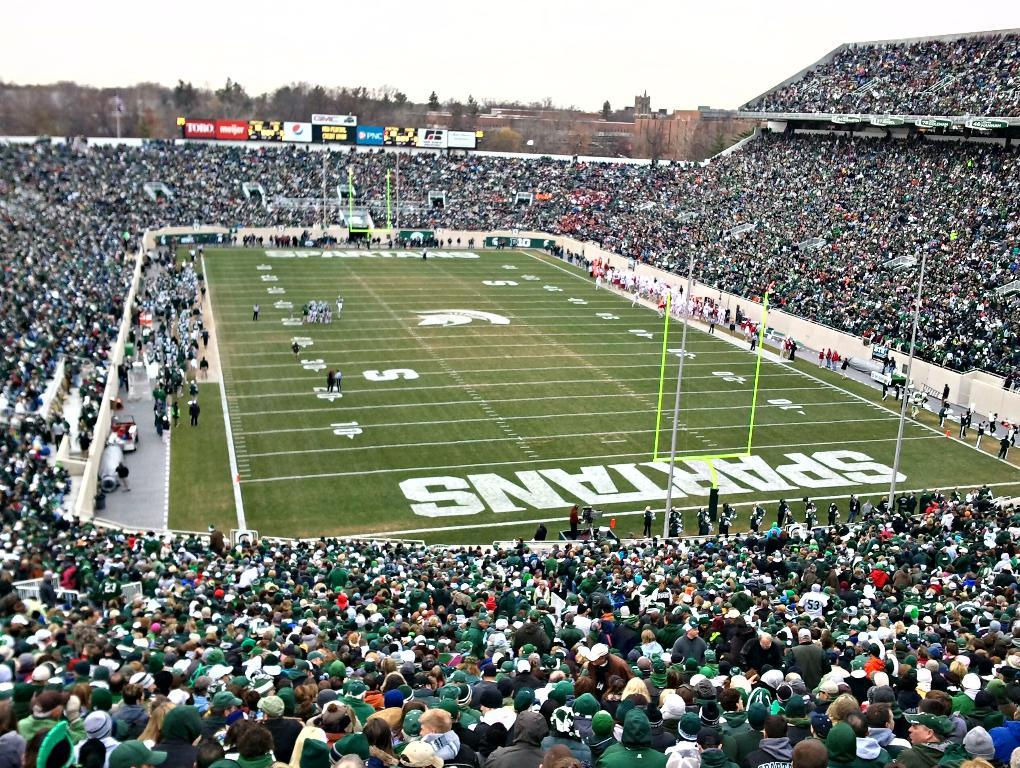<image>
Relay a brief, clear account of the picture shown. The stadium of the Spartans was sold out for the football game. 